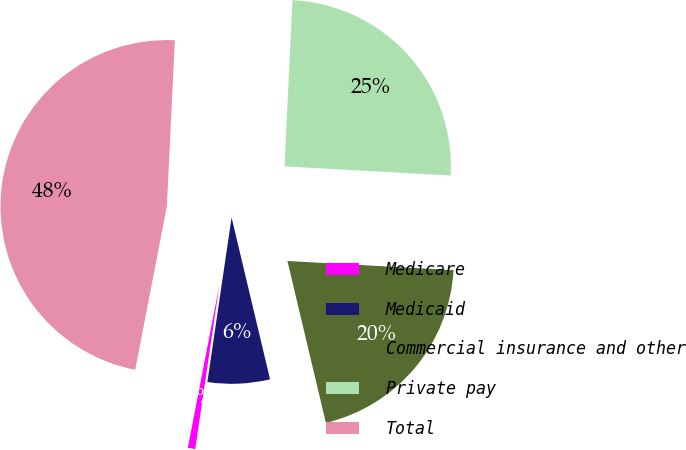Convert chart. <chart><loc_0><loc_0><loc_500><loc_500><pie_chart><fcel>Medicare<fcel>Medicaid<fcel>Commercial insurance and other<fcel>Private pay<fcel>Total<nl><fcel>0.72%<fcel>6.04%<fcel>20.41%<fcel>25.11%<fcel>47.72%<nl></chart> 